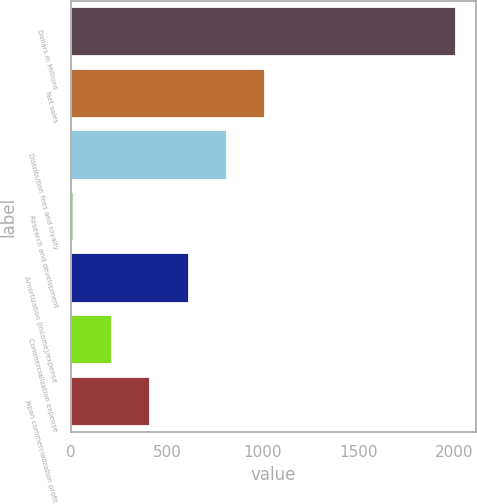<chart> <loc_0><loc_0><loc_500><loc_500><bar_chart><fcel>Dollars in Millions<fcel>Net sales<fcel>Distribution fees and royalty<fcel>Research and development<fcel>Amortization (income)/expense<fcel>Commercialization expense<fcel>Japan commercialization profit<nl><fcel>2012<fcel>1013<fcel>813.2<fcel>14<fcel>613.4<fcel>213.8<fcel>413.6<nl></chart> 